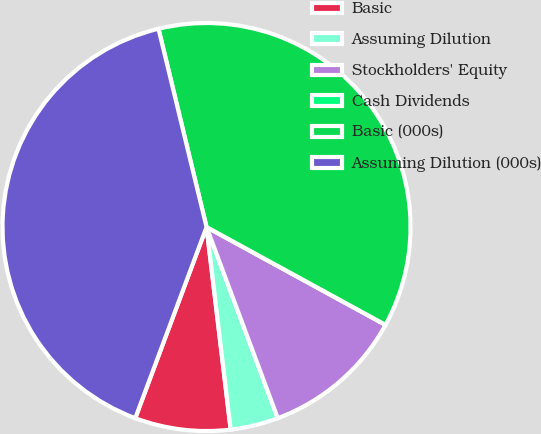Convert chart. <chart><loc_0><loc_0><loc_500><loc_500><pie_chart><fcel>Basic<fcel>Assuming Dilution<fcel>Stockholders' Equity<fcel>Cash Dividends<fcel>Basic (000s)<fcel>Assuming Dilution (000s)<nl><fcel>7.57%<fcel>3.79%<fcel>11.36%<fcel>0.0%<fcel>36.75%<fcel>40.54%<nl></chart> 